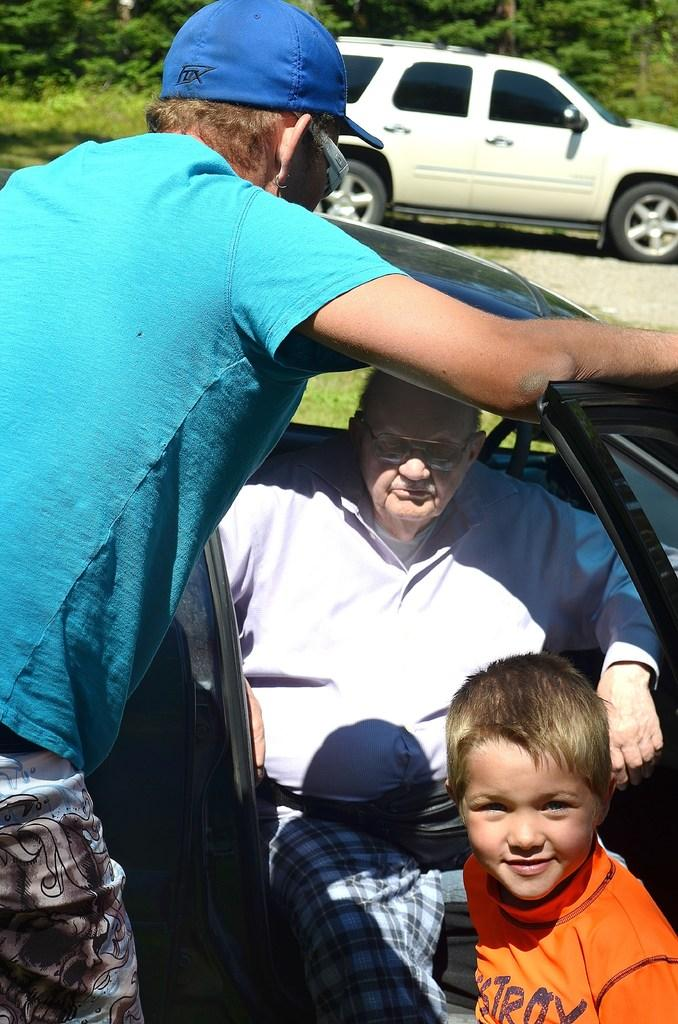What is the man doing in the car? The man is inside the car. Who else is present in the scene besides the man in the car? There is a guy and a boy outside the car. Can you describe the people outside the car? There is a guy and a boy outside the car. What type of waves can be seen crashing on the shore in the image? There are no waves or shore visible in the image; it features a man in a car and people outside the car. 